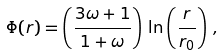Convert formula to latex. <formula><loc_0><loc_0><loc_500><loc_500>\Phi ( r ) = \left ( \frac { 3 \omega + 1 } { 1 + \omega } \right ) \, \ln \left ( \frac { r } { r _ { 0 } } \right ) \, ,</formula> 